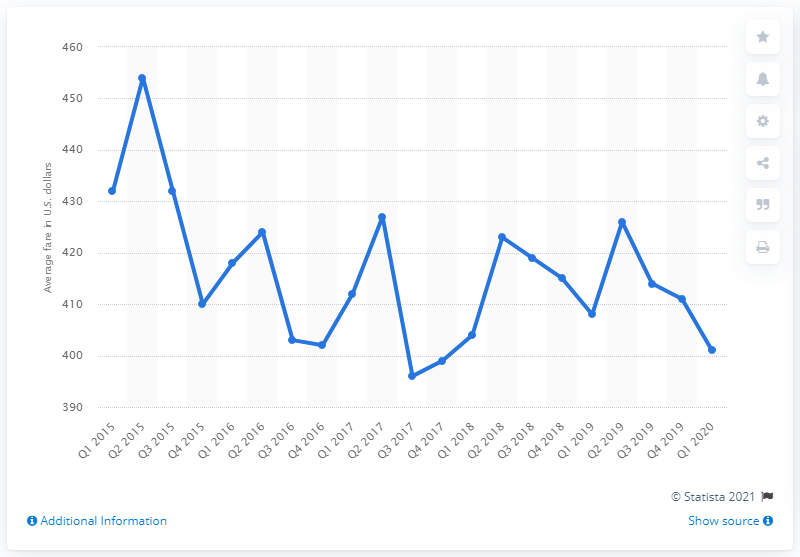List a handful of essential elements in this visual. In the first quarter of 2020, the average fare for a domestic flight was approximately $401. 